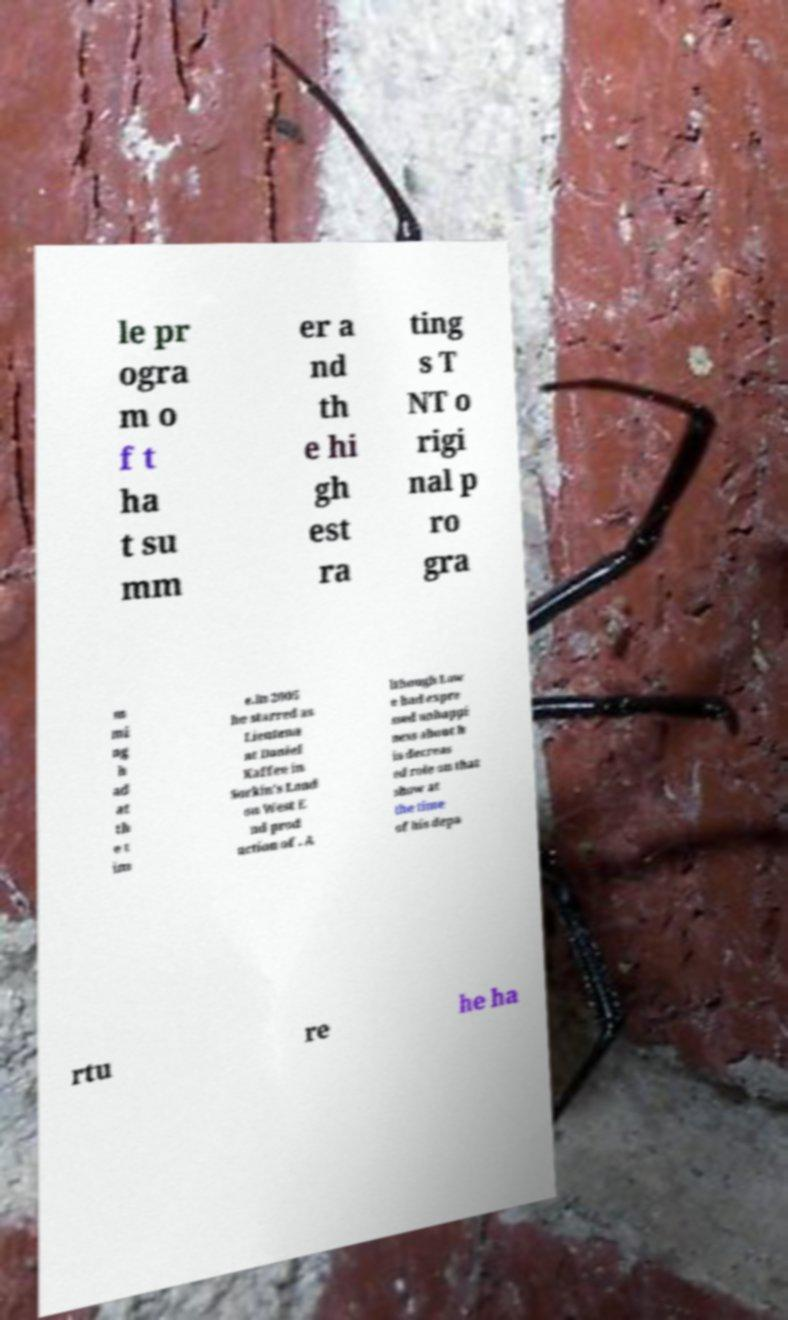Please read and relay the text visible in this image. What does it say? le pr ogra m o f t ha t su mm er a nd th e hi gh est ra ting s T NT o rigi nal p ro gra m mi ng h ad at th e t im e.In 2005 he starred as Lieutena nt Daniel Kaffee in Sorkin's Lond on West E nd prod uction of . A lthough Low e had expre ssed unhappi ness about h is decreas ed role on that show at the time of his depa rtu re he ha 